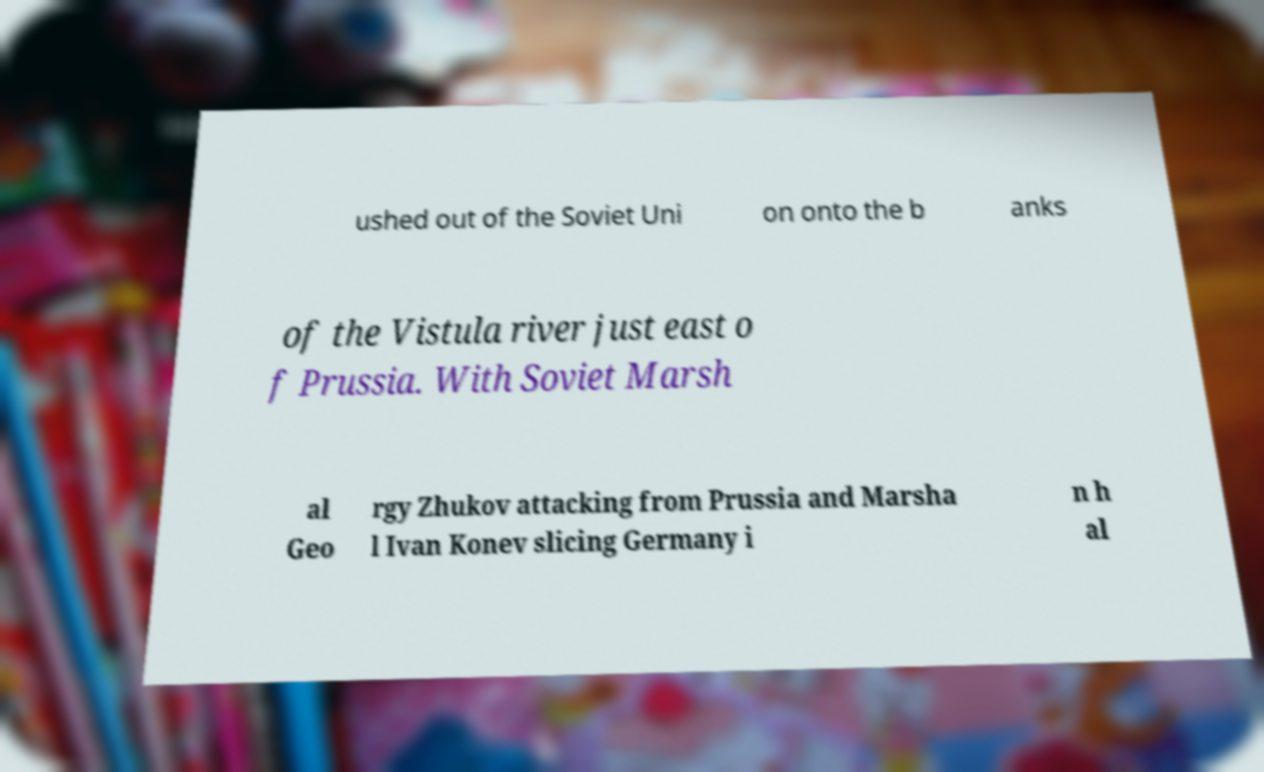Can you accurately transcribe the text from the provided image for me? ushed out of the Soviet Uni on onto the b anks of the Vistula river just east o f Prussia. With Soviet Marsh al Geo rgy Zhukov attacking from Prussia and Marsha l Ivan Konev slicing Germany i n h al 